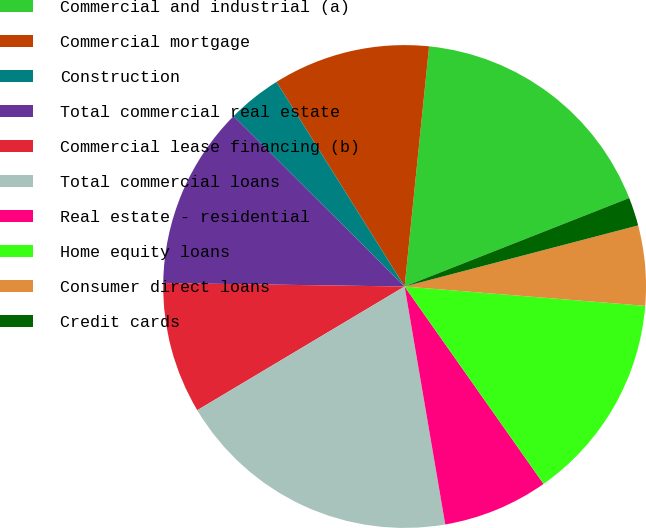<chart> <loc_0><loc_0><loc_500><loc_500><pie_chart><fcel>Commercial and industrial (a)<fcel>Commercial mortgage<fcel>Construction<fcel>Total commercial real estate<fcel>Commercial lease financing (b)<fcel>Total commercial loans<fcel>Real estate - residential<fcel>Home equity loans<fcel>Consumer direct loans<fcel>Credit cards<nl><fcel>17.41%<fcel>10.52%<fcel>3.63%<fcel>12.24%<fcel>8.79%<fcel>19.13%<fcel>7.07%<fcel>13.96%<fcel>5.35%<fcel>1.9%<nl></chart> 